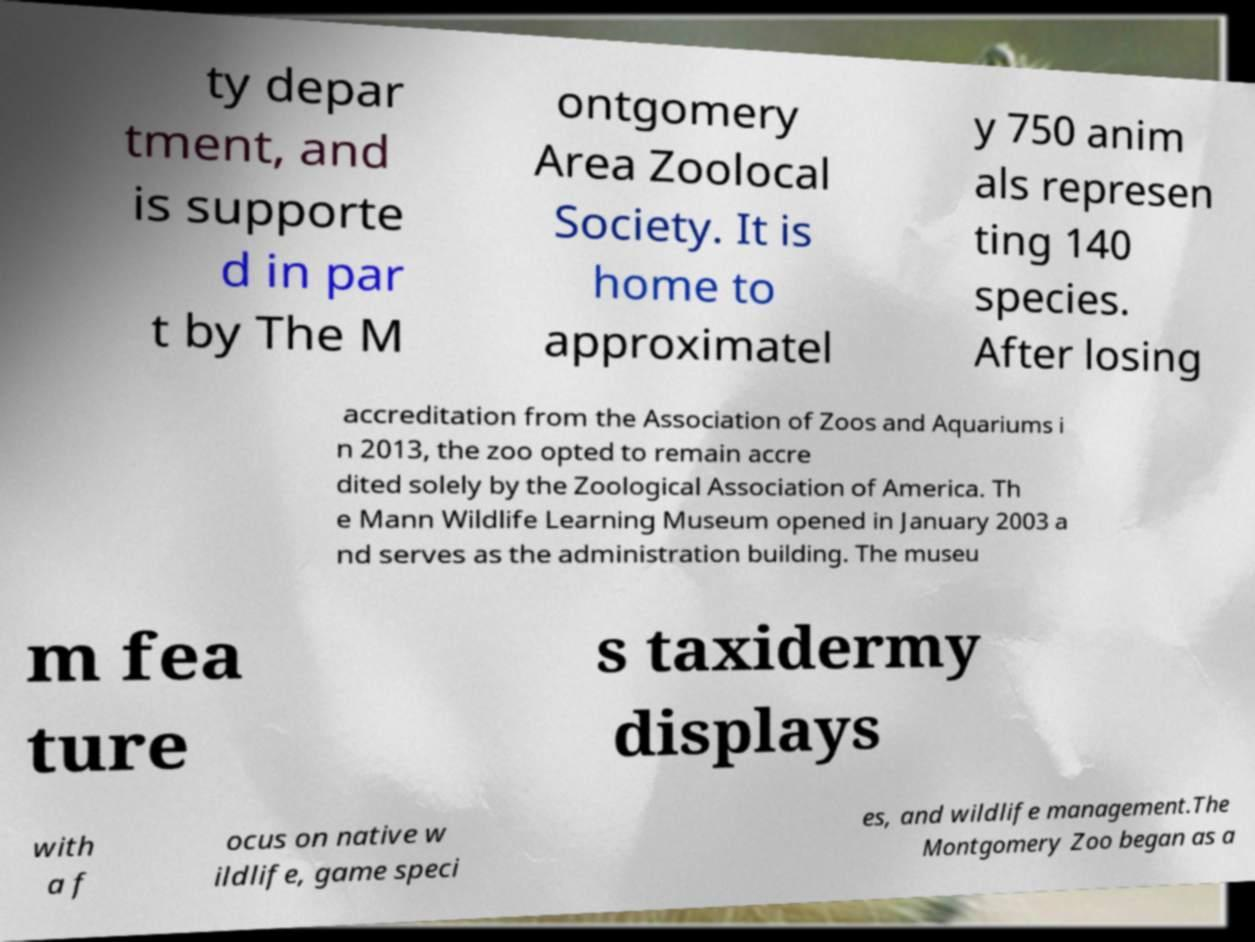For documentation purposes, I need the text within this image transcribed. Could you provide that? ty depar tment, and is supporte d in par t by The M ontgomery Area Zoolocal Society. It is home to approximatel y 750 anim als represen ting 140 species. After losing accreditation from the Association of Zoos and Aquariums i n 2013, the zoo opted to remain accre dited solely by the Zoological Association of America. Th e Mann Wildlife Learning Museum opened in January 2003 a nd serves as the administration building. The museu m fea ture s taxidermy displays with a f ocus on native w ildlife, game speci es, and wildlife management.The Montgomery Zoo began as a 